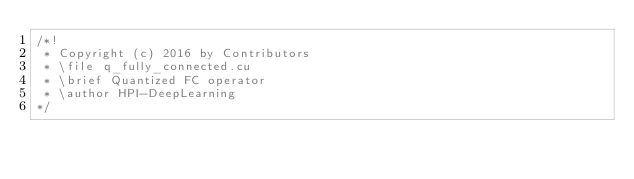<code> <loc_0><loc_0><loc_500><loc_500><_Cuda_>/*!
 * Copyright (c) 2016 by Contributors
 * \file q_fully_connected.cu
 * \brief Quantized FC operator
 * \author HPI-DeepLearning
*/</code> 